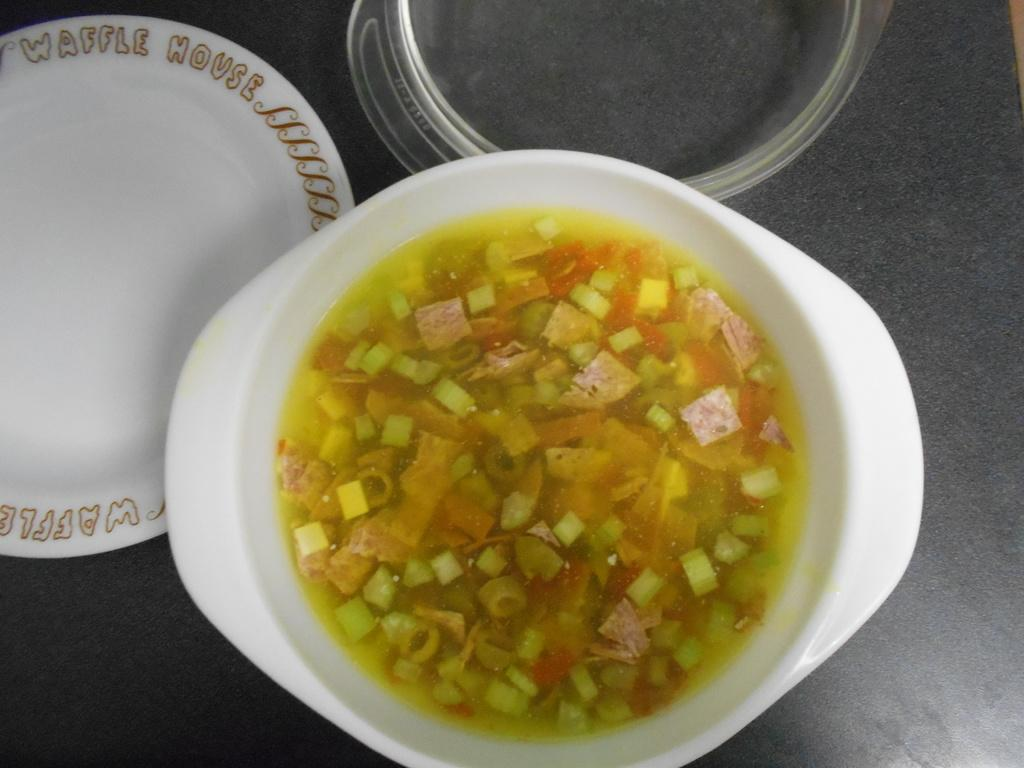What object is located on the left side of the image? There is a white plate on the left side of the image. What can be found in the bowl in the image? There is a bowl of food item in the image. What is placed on a surface in the image? There is a lid on a surface in the image. What type of pump is visible in the image? There is no pump present in the image. What is the name of the thing that is not in the image? It is impossible to name a thing that is not present in the image. 